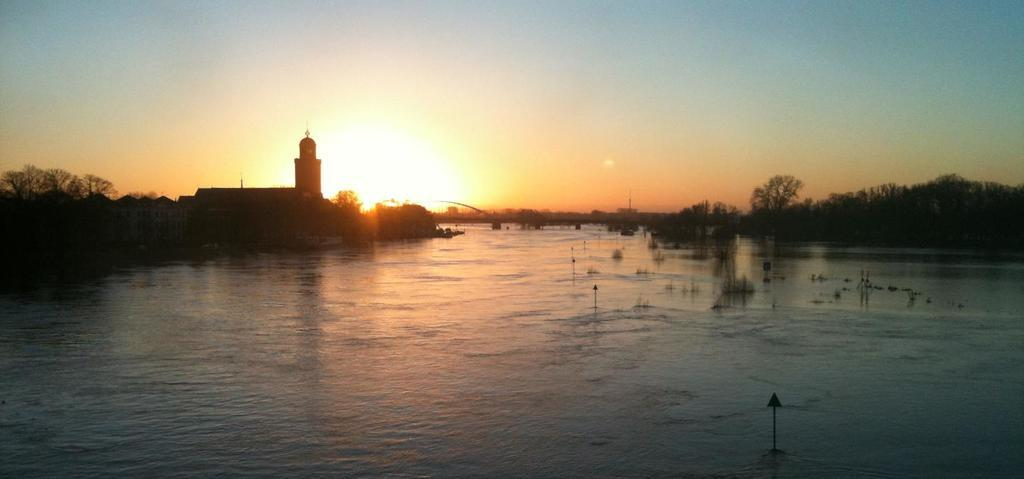What type of structure is present in the image? There is a building in the image. What other natural elements can be seen in the image? There are trees and water visible in the image. What is visible in the background of the image? The sky is visible in the image. What is the source of light in the image? Sunlight is present in the image. How many eyes can be seen on the pan in the image? There is no pan present in the image, and therefore no eyes can be seen on it. 